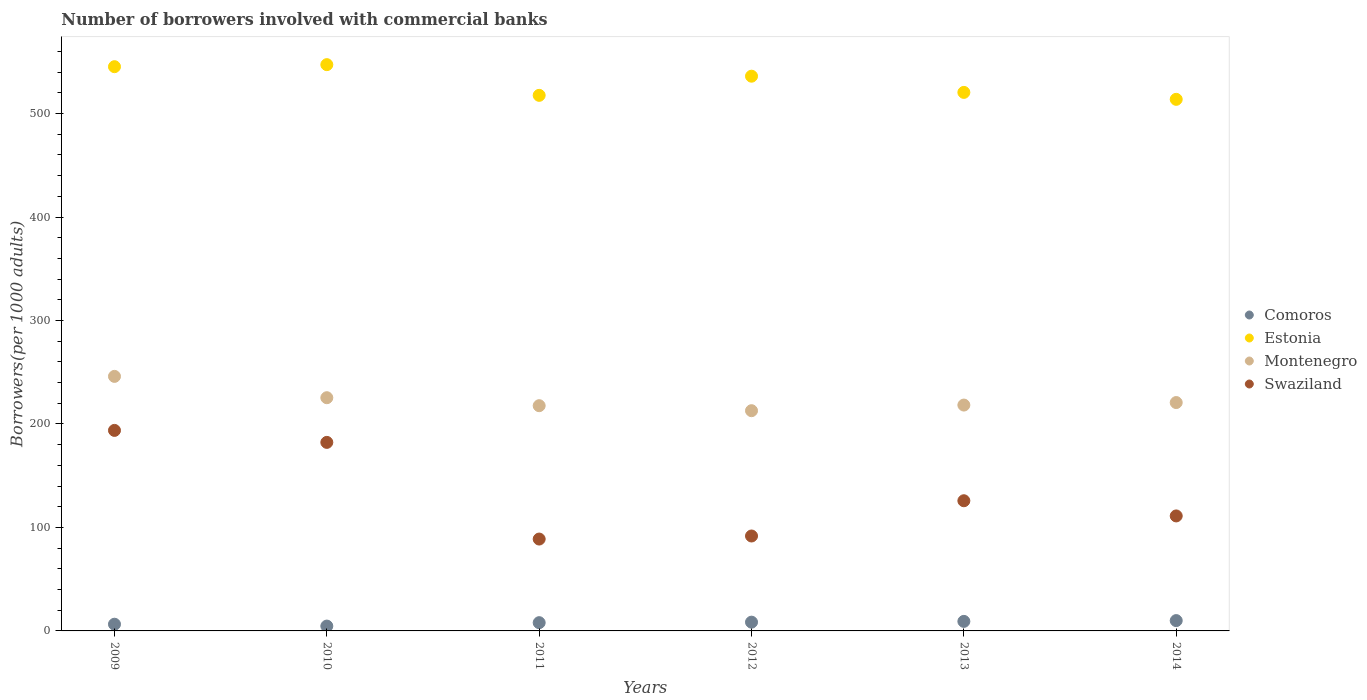How many different coloured dotlines are there?
Make the answer very short. 4. Is the number of dotlines equal to the number of legend labels?
Provide a short and direct response. Yes. What is the number of borrowers involved with commercial banks in Montenegro in 2012?
Ensure brevity in your answer.  212.85. Across all years, what is the maximum number of borrowers involved with commercial banks in Comoros?
Give a very brief answer. 9.98. Across all years, what is the minimum number of borrowers involved with commercial banks in Swaziland?
Your response must be concise. 88.79. In which year was the number of borrowers involved with commercial banks in Comoros maximum?
Your answer should be very brief. 2014. What is the total number of borrowers involved with commercial banks in Swaziland in the graph?
Offer a very short reply. 793.53. What is the difference between the number of borrowers involved with commercial banks in Swaziland in 2009 and that in 2014?
Your answer should be very brief. 82.67. What is the difference between the number of borrowers involved with commercial banks in Montenegro in 2009 and the number of borrowers involved with commercial banks in Comoros in 2010?
Ensure brevity in your answer.  241.33. What is the average number of borrowers involved with commercial banks in Estonia per year?
Provide a succinct answer. 530.13. In the year 2011, what is the difference between the number of borrowers involved with commercial banks in Comoros and number of borrowers involved with commercial banks in Swaziland?
Offer a very short reply. -80.82. What is the ratio of the number of borrowers involved with commercial banks in Montenegro in 2009 to that in 2014?
Ensure brevity in your answer.  1.11. Is the number of borrowers involved with commercial banks in Montenegro in 2009 less than that in 2014?
Your response must be concise. No. What is the difference between the highest and the second highest number of borrowers involved with commercial banks in Swaziland?
Offer a very short reply. 11.59. What is the difference between the highest and the lowest number of borrowers involved with commercial banks in Montenegro?
Your answer should be very brief. 33.16. In how many years, is the number of borrowers involved with commercial banks in Estonia greater than the average number of borrowers involved with commercial banks in Estonia taken over all years?
Your answer should be compact. 3. Is the sum of the number of borrowers involved with commercial banks in Swaziland in 2010 and 2014 greater than the maximum number of borrowers involved with commercial banks in Estonia across all years?
Your response must be concise. No. Is it the case that in every year, the sum of the number of borrowers involved with commercial banks in Estonia and number of borrowers involved with commercial banks in Comoros  is greater than the sum of number of borrowers involved with commercial banks in Swaziland and number of borrowers involved with commercial banks in Montenegro?
Your answer should be very brief. Yes. Does the number of borrowers involved with commercial banks in Estonia monotonically increase over the years?
Your answer should be very brief. No. How many years are there in the graph?
Give a very brief answer. 6. What is the difference between two consecutive major ticks on the Y-axis?
Ensure brevity in your answer.  100. How many legend labels are there?
Offer a terse response. 4. How are the legend labels stacked?
Make the answer very short. Vertical. What is the title of the graph?
Ensure brevity in your answer.  Number of borrowers involved with commercial banks. What is the label or title of the X-axis?
Give a very brief answer. Years. What is the label or title of the Y-axis?
Your answer should be very brief. Borrowers(per 1000 adults). What is the Borrowers(per 1000 adults) in Comoros in 2009?
Provide a short and direct response. 6.48. What is the Borrowers(per 1000 adults) in Estonia in 2009?
Give a very brief answer. 545.35. What is the Borrowers(per 1000 adults) of Montenegro in 2009?
Ensure brevity in your answer.  246.02. What is the Borrowers(per 1000 adults) of Swaziland in 2009?
Offer a very short reply. 193.81. What is the Borrowers(per 1000 adults) of Comoros in 2010?
Ensure brevity in your answer.  4.68. What is the Borrowers(per 1000 adults) in Estonia in 2010?
Provide a succinct answer. 547.32. What is the Borrowers(per 1000 adults) in Montenegro in 2010?
Provide a succinct answer. 225.41. What is the Borrowers(per 1000 adults) in Swaziland in 2010?
Your response must be concise. 182.22. What is the Borrowers(per 1000 adults) of Comoros in 2011?
Make the answer very short. 7.98. What is the Borrowers(per 1000 adults) of Estonia in 2011?
Offer a very short reply. 517.65. What is the Borrowers(per 1000 adults) in Montenegro in 2011?
Ensure brevity in your answer.  217.69. What is the Borrowers(per 1000 adults) in Swaziland in 2011?
Make the answer very short. 88.79. What is the Borrowers(per 1000 adults) in Comoros in 2012?
Provide a short and direct response. 8.47. What is the Borrowers(per 1000 adults) of Estonia in 2012?
Provide a succinct answer. 536.16. What is the Borrowers(per 1000 adults) of Montenegro in 2012?
Make the answer very short. 212.85. What is the Borrowers(per 1000 adults) in Swaziland in 2012?
Your answer should be compact. 91.75. What is the Borrowers(per 1000 adults) of Comoros in 2013?
Ensure brevity in your answer.  9.21. What is the Borrowers(per 1000 adults) in Estonia in 2013?
Your response must be concise. 520.5. What is the Borrowers(per 1000 adults) of Montenegro in 2013?
Make the answer very short. 218.3. What is the Borrowers(per 1000 adults) in Swaziland in 2013?
Provide a succinct answer. 125.82. What is the Borrowers(per 1000 adults) in Comoros in 2014?
Offer a terse response. 9.98. What is the Borrowers(per 1000 adults) of Estonia in 2014?
Offer a very short reply. 513.79. What is the Borrowers(per 1000 adults) in Montenegro in 2014?
Your answer should be very brief. 220.72. What is the Borrowers(per 1000 adults) of Swaziland in 2014?
Ensure brevity in your answer.  111.14. Across all years, what is the maximum Borrowers(per 1000 adults) of Comoros?
Make the answer very short. 9.98. Across all years, what is the maximum Borrowers(per 1000 adults) of Estonia?
Offer a very short reply. 547.32. Across all years, what is the maximum Borrowers(per 1000 adults) of Montenegro?
Make the answer very short. 246.02. Across all years, what is the maximum Borrowers(per 1000 adults) in Swaziland?
Make the answer very short. 193.81. Across all years, what is the minimum Borrowers(per 1000 adults) of Comoros?
Your answer should be compact. 4.68. Across all years, what is the minimum Borrowers(per 1000 adults) in Estonia?
Offer a terse response. 513.79. Across all years, what is the minimum Borrowers(per 1000 adults) in Montenegro?
Offer a terse response. 212.85. Across all years, what is the minimum Borrowers(per 1000 adults) in Swaziland?
Provide a short and direct response. 88.79. What is the total Borrowers(per 1000 adults) of Comoros in the graph?
Offer a terse response. 46.79. What is the total Borrowers(per 1000 adults) of Estonia in the graph?
Offer a terse response. 3180.77. What is the total Borrowers(per 1000 adults) of Montenegro in the graph?
Provide a succinct answer. 1340.98. What is the total Borrowers(per 1000 adults) in Swaziland in the graph?
Ensure brevity in your answer.  793.53. What is the difference between the Borrowers(per 1000 adults) of Comoros in 2009 and that in 2010?
Offer a very short reply. 1.79. What is the difference between the Borrowers(per 1000 adults) in Estonia in 2009 and that in 2010?
Make the answer very short. -1.97. What is the difference between the Borrowers(per 1000 adults) of Montenegro in 2009 and that in 2010?
Keep it short and to the point. 20.61. What is the difference between the Borrowers(per 1000 adults) of Swaziland in 2009 and that in 2010?
Keep it short and to the point. 11.59. What is the difference between the Borrowers(per 1000 adults) of Comoros in 2009 and that in 2011?
Offer a very short reply. -1.5. What is the difference between the Borrowers(per 1000 adults) in Estonia in 2009 and that in 2011?
Make the answer very short. 27.7. What is the difference between the Borrowers(per 1000 adults) of Montenegro in 2009 and that in 2011?
Offer a terse response. 28.33. What is the difference between the Borrowers(per 1000 adults) in Swaziland in 2009 and that in 2011?
Your response must be concise. 105.02. What is the difference between the Borrowers(per 1000 adults) in Comoros in 2009 and that in 2012?
Your response must be concise. -1.99. What is the difference between the Borrowers(per 1000 adults) in Estonia in 2009 and that in 2012?
Your response must be concise. 9.19. What is the difference between the Borrowers(per 1000 adults) in Montenegro in 2009 and that in 2012?
Provide a short and direct response. 33.16. What is the difference between the Borrowers(per 1000 adults) in Swaziland in 2009 and that in 2012?
Provide a short and direct response. 102.06. What is the difference between the Borrowers(per 1000 adults) in Comoros in 2009 and that in 2013?
Offer a terse response. -2.74. What is the difference between the Borrowers(per 1000 adults) in Estonia in 2009 and that in 2013?
Your answer should be compact. 24.85. What is the difference between the Borrowers(per 1000 adults) of Montenegro in 2009 and that in 2013?
Offer a terse response. 27.72. What is the difference between the Borrowers(per 1000 adults) of Swaziland in 2009 and that in 2013?
Give a very brief answer. 67.99. What is the difference between the Borrowers(per 1000 adults) of Comoros in 2009 and that in 2014?
Your answer should be compact. -3.5. What is the difference between the Borrowers(per 1000 adults) in Estonia in 2009 and that in 2014?
Offer a very short reply. 31.56. What is the difference between the Borrowers(per 1000 adults) in Montenegro in 2009 and that in 2014?
Offer a terse response. 25.29. What is the difference between the Borrowers(per 1000 adults) in Swaziland in 2009 and that in 2014?
Keep it short and to the point. 82.67. What is the difference between the Borrowers(per 1000 adults) in Comoros in 2010 and that in 2011?
Provide a short and direct response. -3.3. What is the difference between the Borrowers(per 1000 adults) in Estonia in 2010 and that in 2011?
Make the answer very short. 29.67. What is the difference between the Borrowers(per 1000 adults) of Montenegro in 2010 and that in 2011?
Your answer should be compact. 7.72. What is the difference between the Borrowers(per 1000 adults) of Swaziland in 2010 and that in 2011?
Your answer should be compact. 93.43. What is the difference between the Borrowers(per 1000 adults) in Comoros in 2010 and that in 2012?
Your answer should be very brief. -3.78. What is the difference between the Borrowers(per 1000 adults) of Estonia in 2010 and that in 2012?
Make the answer very short. 11.16. What is the difference between the Borrowers(per 1000 adults) of Montenegro in 2010 and that in 2012?
Make the answer very short. 12.55. What is the difference between the Borrowers(per 1000 adults) of Swaziland in 2010 and that in 2012?
Offer a very short reply. 90.48. What is the difference between the Borrowers(per 1000 adults) in Comoros in 2010 and that in 2013?
Offer a very short reply. -4.53. What is the difference between the Borrowers(per 1000 adults) of Estonia in 2010 and that in 2013?
Your response must be concise. 26.82. What is the difference between the Borrowers(per 1000 adults) in Montenegro in 2010 and that in 2013?
Make the answer very short. 7.11. What is the difference between the Borrowers(per 1000 adults) in Swaziland in 2010 and that in 2013?
Provide a succinct answer. 56.4. What is the difference between the Borrowers(per 1000 adults) of Comoros in 2010 and that in 2014?
Your answer should be compact. -5.3. What is the difference between the Borrowers(per 1000 adults) in Estonia in 2010 and that in 2014?
Give a very brief answer. 33.53. What is the difference between the Borrowers(per 1000 adults) of Montenegro in 2010 and that in 2014?
Your response must be concise. 4.68. What is the difference between the Borrowers(per 1000 adults) in Swaziland in 2010 and that in 2014?
Your answer should be very brief. 71.08. What is the difference between the Borrowers(per 1000 adults) in Comoros in 2011 and that in 2012?
Your answer should be very brief. -0.49. What is the difference between the Borrowers(per 1000 adults) of Estonia in 2011 and that in 2012?
Your answer should be very brief. -18.51. What is the difference between the Borrowers(per 1000 adults) of Montenegro in 2011 and that in 2012?
Make the answer very short. 4.83. What is the difference between the Borrowers(per 1000 adults) in Swaziland in 2011 and that in 2012?
Ensure brevity in your answer.  -2.95. What is the difference between the Borrowers(per 1000 adults) in Comoros in 2011 and that in 2013?
Offer a terse response. -1.23. What is the difference between the Borrowers(per 1000 adults) of Estonia in 2011 and that in 2013?
Offer a very short reply. -2.85. What is the difference between the Borrowers(per 1000 adults) in Montenegro in 2011 and that in 2013?
Provide a short and direct response. -0.61. What is the difference between the Borrowers(per 1000 adults) of Swaziland in 2011 and that in 2013?
Keep it short and to the point. -37.03. What is the difference between the Borrowers(per 1000 adults) in Comoros in 2011 and that in 2014?
Offer a very short reply. -2. What is the difference between the Borrowers(per 1000 adults) in Estonia in 2011 and that in 2014?
Offer a terse response. 3.86. What is the difference between the Borrowers(per 1000 adults) of Montenegro in 2011 and that in 2014?
Your answer should be compact. -3.03. What is the difference between the Borrowers(per 1000 adults) in Swaziland in 2011 and that in 2014?
Offer a terse response. -22.35. What is the difference between the Borrowers(per 1000 adults) in Comoros in 2012 and that in 2013?
Your answer should be very brief. -0.75. What is the difference between the Borrowers(per 1000 adults) in Estonia in 2012 and that in 2013?
Offer a very short reply. 15.66. What is the difference between the Borrowers(per 1000 adults) of Montenegro in 2012 and that in 2013?
Offer a terse response. -5.44. What is the difference between the Borrowers(per 1000 adults) of Swaziland in 2012 and that in 2013?
Keep it short and to the point. -34.08. What is the difference between the Borrowers(per 1000 adults) of Comoros in 2012 and that in 2014?
Provide a short and direct response. -1.51. What is the difference between the Borrowers(per 1000 adults) in Estonia in 2012 and that in 2014?
Offer a very short reply. 22.37. What is the difference between the Borrowers(per 1000 adults) in Montenegro in 2012 and that in 2014?
Your answer should be compact. -7.87. What is the difference between the Borrowers(per 1000 adults) of Swaziland in 2012 and that in 2014?
Offer a terse response. -19.4. What is the difference between the Borrowers(per 1000 adults) in Comoros in 2013 and that in 2014?
Provide a short and direct response. -0.77. What is the difference between the Borrowers(per 1000 adults) of Estonia in 2013 and that in 2014?
Make the answer very short. 6.71. What is the difference between the Borrowers(per 1000 adults) in Montenegro in 2013 and that in 2014?
Your response must be concise. -2.42. What is the difference between the Borrowers(per 1000 adults) in Swaziland in 2013 and that in 2014?
Your response must be concise. 14.68. What is the difference between the Borrowers(per 1000 adults) in Comoros in 2009 and the Borrowers(per 1000 adults) in Estonia in 2010?
Provide a short and direct response. -540.84. What is the difference between the Borrowers(per 1000 adults) in Comoros in 2009 and the Borrowers(per 1000 adults) in Montenegro in 2010?
Give a very brief answer. -218.93. What is the difference between the Borrowers(per 1000 adults) in Comoros in 2009 and the Borrowers(per 1000 adults) in Swaziland in 2010?
Make the answer very short. -175.75. What is the difference between the Borrowers(per 1000 adults) in Estonia in 2009 and the Borrowers(per 1000 adults) in Montenegro in 2010?
Your answer should be compact. 319.94. What is the difference between the Borrowers(per 1000 adults) of Estonia in 2009 and the Borrowers(per 1000 adults) of Swaziland in 2010?
Offer a terse response. 363.13. What is the difference between the Borrowers(per 1000 adults) of Montenegro in 2009 and the Borrowers(per 1000 adults) of Swaziland in 2010?
Your response must be concise. 63.79. What is the difference between the Borrowers(per 1000 adults) of Comoros in 2009 and the Borrowers(per 1000 adults) of Estonia in 2011?
Your answer should be compact. -511.17. What is the difference between the Borrowers(per 1000 adults) of Comoros in 2009 and the Borrowers(per 1000 adults) of Montenegro in 2011?
Offer a terse response. -211.21. What is the difference between the Borrowers(per 1000 adults) of Comoros in 2009 and the Borrowers(per 1000 adults) of Swaziland in 2011?
Ensure brevity in your answer.  -82.32. What is the difference between the Borrowers(per 1000 adults) in Estonia in 2009 and the Borrowers(per 1000 adults) in Montenegro in 2011?
Make the answer very short. 327.66. What is the difference between the Borrowers(per 1000 adults) in Estonia in 2009 and the Borrowers(per 1000 adults) in Swaziland in 2011?
Provide a short and direct response. 456.56. What is the difference between the Borrowers(per 1000 adults) of Montenegro in 2009 and the Borrowers(per 1000 adults) of Swaziland in 2011?
Offer a very short reply. 157.22. What is the difference between the Borrowers(per 1000 adults) of Comoros in 2009 and the Borrowers(per 1000 adults) of Estonia in 2012?
Your response must be concise. -529.68. What is the difference between the Borrowers(per 1000 adults) of Comoros in 2009 and the Borrowers(per 1000 adults) of Montenegro in 2012?
Ensure brevity in your answer.  -206.38. What is the difference between the Borrowers(per 1000 adults) in Comoros in 2009 and the Borrowers(per 1000 adults) in Swaziland in 2012?
Your response must be concise. -85.27. What is the difference between the Borrowers(per 1000 adults) in Estonia in 2009 and the Borrowers(per 1000 adults) in Montenegro in 2012?
Offer a very short reply. 332.5. What is the difference between the Borrowers(per 1000 adults) of Estonia in 2009 and the Borrowers(per 1000 adults) of Swaziland in 2012?
Your response must be concise. 453.6. What is the difference between the Borrowers(per 1000 adults) of Montenegro in 2009 and the Borrowers(per 1000 adults) of Swaziland in 2012?
Offer a terse response. 154.27. What is the difference between the Borrowers(per 1000 adults) of Comoros in 2009 and the Borrowers(per 1000 adults) of Estonia in 2013?
Keep it short and to the point. -514.02. What is the difference between the Borrowers(per 1000 adults) in Comoros in 2009 and the Borrowers(per 1000 adults) in Montenegro in 2013?
Give a very brief answer. -211.82. What is the difference between the Borrowers(per 1000 adults) in Comoros in 2009 and the Borrowers(per 1000 adults) in Swaziland in 2013?
Ensure brevity in your answer.  -119.35. What is the difference between the Borrowers(per 1000 adults) in Estonia in 2009 and the Borrowers(per 1000 adults) in Montenegro in 2013?
Your answer should be very brief. 327.05. What is the difference between the Borrowers(per 1000 adults) in Estonia in 2009 and the Borrowers(per 1000 adults) in Swaziland in 2013?
Make the answer very short. 419.53. What is the difference between the Borrowers(per 1000 adults) in Montenegro in 2009 and the Borrowers(per 1000 adults) in Swaziland in 2013?
Ensure brevity in your answer.  120.19. What is the difference between the Borrowers(per 1000 adults) in Comoros in 2009 and the Borrowers(per 1000 adults) in Estonia in 2014?
Your answer should be very brief. -507.32. What is the difference between the Borrowers(per 1000 adults) in Comoros in 2009 and the Borrowers(per 1000 adults) in Montenegro in 2014?
Offer a terse response. -214.25. What is the difference between the Borrowers(per 1000 adults) of Comoros in 2009 and the Borrowers(per 1000 adults) of Swaziland in 2014?
Ensure brevity in your answer.  -104.67. What is the difference between the Borrowers(per 1000 adults) in Estonia in 2009 and the Borrowers(per 1000 adults) in Montenegro in 2014?
Your response must be concise. 324.63. What is the difference between the Borrowers(per 1000 adults) of Estonia in 2009 and the Borrowers(per 1000 adults) of Swaziland in 2014?
Provide a short and direct response. 434.21. What is the difference between the Borrowers(per 1000 adults) in Montenegro in 2009 and the Borrowers(per 1000 adults) in Swaziland in 2014?
Your response must be concise. 134.87. What is the difference between the Borrowers(per 1000 adults) of Comoros in 2010 and the Borrowers(per 1000 adults) of Estonia in 2011?
Your answer should be compact. -512.97. What is the difference between the Borrowers(per 1000 adults) of Comoros in 2010 and the Borrowers(per 1000 adults) of Montenegro in 2011?
Provide a short and direct response. -213.01. What is the difference between the Borrowers(per 1000 adults) of Comoros in 2010 and the Borrowers(per 1000 adults) of Swaziland in 2011?
Make the answer very short. -84.11. What is the difference between the Borrowers(per 1000 adults) in Estonia in 2010 and the Borrowers(per 1000 adults) in Montenegro in 2011?
Make the answer very short. 329.63. What is the difference between the Borrowers(per 1000 adults) in Estonia in 2010 and the Borrowers(per 1000 adults) in Swaziland in 2011?
Make the answer very short. 458.53. What is the difference between the Borrowers(per 1000 adults) in Montenegro in 2010 and the Borrowers(per 1000 adults) in Swaziland in 2011?
Ensure brevity in your answer.  136.61. What is the difference between the Borrowers(per 1000 adults) in Comoros in 2010 and the Borrowers(per 1000 adults) in Estonia in 2012?
Keep it short and to the point. -531.48. What is the difference between the Borrowers(per 1000 adults) in Comoros in 2010 and the Borrowers(per 1000 adults) in Montenegro in 2012?
Your answer should be very brief. -208.17. What is the difference between the Borrowers(per 1000 adults) in Comoros in 2010 and the Borrowers(per 1000 adults) in Swaziland in 2012?
Ensure brevity in your answer.  -87.06. What is the difference between the Borrowers(per 1000 adults) of Estonia in 2010 and the Borrowers(per 1000 adults) of Montenegro in 2012?
Offer a terse response. 334.47. What is the difference between the Borrowers(per 1000 adults) of Estonia in 2010 and the Borrowers(per 1000 adults) of Swaziland in 2012?
Offer a very short reply. 455.57. What is the difference between the Borrowers(per 1000 adults) of Montenegro in 2010 and the Borrowers(per 1000 adults) of Swaziland in 2012?
Offer a very short reply. 133.66. What is the difference between the Borrowers(per 1000 adults) of Comoros in 2010 and the Borrowers(per 1000 adults) of Estonia in 2013?
Give a very brief answer. -515.82. What is the difference between the Borrowers(per 1000 adults) in Comoros in 2010 and the Borrowers(per 1000 adults) in Montenegro in 2013?
Your answer should be compact. -213.62. What is the difference between the Borrowers(per 1000 adults) in Comoros in 2010 and the Borrowers(per 1000 adults) in Swaziland in 2013?
Make the answer very short. -121.14. What is the difference between the Borrowers(per 1000 adults) of Estonia in 2010 and the Borrowers(per 1000 adults) of Montenegro in 2013?
Your answer should be very brief. 329.02. What is the difference between the Borrowers(per 1000 adults) in Estonia in 2010 and the Borrowers(per 1000 adults) in Swaziland in 2013?
Make the answer very short. 421.5. What is the difference between the Borrowers(per 1000 adults) of Montenegro in 2010 and the Borrowers(per 1000 adults) of Swaziland in 2013?
Provide a succinct answer. 99.59. What is the difference between the Borrowers(per 1000 adults) of Comoros in 2010 and the Borrowers(per 1000 adults) of Estonia in 2014?
Keep it short and to the point. -509.11. What is the difference between the Borrowers(per 1000 adults) of Comoros in 2010 and the Borrowers(per 1000 adults) of Montenegro in 2014?
Offer a terse response. -216.04. What is the difference between the Borrowers(per 1000 adults) of Comoros in 2010 and the Borrowers(per 1000 adults) of Swaziland in 2014?
Your response must be concise. -106.46. What is the difference between the Borrowers(per 1000 adults) in Estonia in 2010 and the Borrowers(per 1000 adults) in Montenegro in 2014?
Offer a terse response. 326.6. What is the difference between the Borrowers(per 1000 adults) in Estonia in 2010 and the Borrowers(per 1000 adults) in Swaziland in 2014?
Your answer should be compact. 436.18. What is the difference between the Borrowers(per 1000 adults) of Montenegro in 2010 and the Borrowers(per 1000 adults) of Swaziland in 2014?
Provide a short and direct response. 114.27. What is the difference between the Borrowers(per 1000 adults) in Comoros in 2011 and the Borrowers(per 1000 adults) in Estonia in 2012?
Your answer should be compact. -528.18. What is the difference between the Borrowers(per 1000 adults) of Comoros in 2011 and the Borrowers(per 1000 adults) of Montenegro in 2012?
Your answer should be compact. -204.88. What is the difference between the Borrowers(per 1000 adults) in Comoros in 2011 and the Borrowers(per 1000 adults) in Swaziland in 2012?
Give a very brief answer. -83.77. What is the difference between the Borrowers(per 1000 adults) of Estonia in 2011 and the Borrowers(per 1000 adults) of Montenegro in 2012?
Your answer should be compact. 304.79. What is the difference between the Borrowers(per 1000 adults) in Estonia in 2011 and the Borrowers(per 1000 adults) in Swaziland in 2012?
Offer a very short reply. 425.9. What is the difference between the Borrowers(per 1000 adults) in Montenegro in 2011 and the Borrowers(per 1000 adults) in Swaziland in 2012?
Give a very brief answer. 125.94. What is the difference between the Borrowers(per 1000 adults) of Comoros in 2011 and the Borrowers(per 1000 adults) of Estonia in 2013?
Ensure brevity in your answer.  -512.52. What is the difference between the Borrowers(per 1000 adults) in Comoros in 2011 and the Borrowers(per 1000 adults) in Montenegro in 2013?
Your response must be concise. -210.32. What is the difference between the Borrowers(per 1000 adults) in Comoros in 2011 and the Borrowers(per 1000 adults) in Swaziland in 2013?
Give a very brief answer. -117.84. What is the difference between the Borrowers(per 1000 adults) of Estonia in 2011 and the Borrowers(per 1000 adults) of Montenegro in 2013?
Offer a terse response. 299.35. What is the difference between the Borrowers(per 1000 adults) in Estonia in 2011 and the Borrowers(per 1000 adults) in Swaziland in 2013?
Offer a terse response. 391.83. What is the difference between the Borrowers(per 1000 adults) in Montenegro in 2011 and the Borrowers(per 1000 adults) in Swaziland in 2013?
Your answer should be very brief. 91.87. What is the difference between the Borrowers(per 1000 adults) in Comoros in 2011 and the Borrowers(per 1000 adults) in Estonia in 2014?
Ensure brevity in your answer.  -505.81. What is the difference between the Borrowers(per 1000 adults) of Comoros in 2011 and the Borrowers(per 1000 adults) of Montenegro in 2014?
Your answer should be very brief. -212.74. What is the difference between the Borrowers(per 1000 adults) in Comoros in 2011 and the Borrowers(per 1000 adults) in Swaziland in 2014?
Ensure brevity in your answer.  -103.16. What is the difference between the Borrowers(per 1000 adults) in Estonia in 2011 and the Borrowers(per 1000 adults) in Montenegro in 2014?
Make the answer very short. 296.93. What is the difference between the Borrowers(per 1000 adults) of Estonia in 2011 and the Borrowers(per 1000 adults) of Swaziland in 2014?
Ensure brevity in your answer.  406.51. What is the difference between the Borrowers(per 1000 adults) in Montenegro in 2011 and the Borrowers(per 1000 adults) in Swaziland in 2014?
Your response must be concise. 106.55. What is the difference between the Borrowers(per 1000 adults) in Comoros in 2012 and the Borrowers(per 1000 adults) in Estonia in 2013?
Keep it short and to the point. -512.03. What is the difference between the Borrowers(per 1000 adults) of Comoros in 2012 and the Borrowers(per 1000 adults) of Montenegro in 2013?
Your answer should be very brief. -209.83. What is the difference between the Borrowers(per 1000 adults) in Comoros in 2012 and the Borrowers(per 1000 adults) in Swaziland in 2013?
Your response must be concise. -117.35. What is the difference between the Borrowers(per 1000 adults) of Estonia in 2012 and the Borrowers(per 1000 adults) of Montenegro in 2013?
Provide a succinct answer. 317.86. What is the difference between the Borrowers(per 1000 adults) in Estonia in 2012 and the Borrowers(per 1000 adults) in Swaziland in 2013?
Ensure brevity in your answer.  410.34. What is the difference between the Borrowers(per 1000 adults) in Montenegro in 2012 and the Borrowers(per 1000 adults) in Swaziland in 2013?
Your answer should be compact. 87.03. What is the difference between the Borrowers(per 1000 adults) of Comoros in 2012 and the Borrowers(per 1000 adults) of Estonia in 2014?
Your answer should be compact. -505.33. What is the difference between the Borrowers(per 1000 adults) of Comoros in 2012 and the Borrowers(per 1000 adults) of Montenegro in 2014?
Your answer should be very brief. -212.26. What is the difference between the Borrowers(per 1000 adults) of Comoros in 2012 and the Borrowers(per 1000 adults) of Swaziland in 2014?
Offer a very short reply. -102.68. What is the difference between the Borrowers(per 1000 adults) of Estonia in 2012 and the Borrowers(per 1000 adults) of Montenegro in 2014?
Offer a terse response. 315.44. What is the difference between the Borrowers(per 1000 adults) in Estonia in 2012 and the Borrowers(per 1000 adults) in Swaziland in 2014?
Your response must be concise. 425.02. What is the difference between the Borrowers(per 1000 adults) of Montenegro in 2012 and the Borrowers(per 1000 adults) of Swaziland in 2014?
Your response must be concise. 101.71. What is the difference between the Borrowers(per 1000 adults) in Comoros in 2013 and the Borrowers(per 1000 adults) in Estonia in 2014?
Give a very brief answer. -504.58. What is the difference between the Borrowers(per 1000 adults) of Comoros in 2013 and the Borrowers(per 1000 adults) of Montenegro in 2014?
Offer a terse response. -211.51. What is the difference between the Borrowers(per 1000 adults) in Comoros in 2013 and the Borrowers(per 1000 adults) in Swaziland in 2014?
Keep it short and to the point. -101.93. What is the difference between the Borrowers(per 1000 adults) in Estonia in 2013 and the Borrowers(per 1000 adults) in Montenegro in 2014?
Offer a very short reply. 299.78. What is the difference between the Borrowers(per 1000 adults) of Estonia in 2013 and the Borrowers(per 1000 adults) of Swaziland in 2014?
Your answer should be compact. 409.36. What is the difference between the Borrowers(per 1000 adults) in Montenegro in 2013 and the Borrowers(per 1000 adults) in Swaziland in 2014?
Give a very brief answer. 107.16. What is the average Borrowers(per 1000 adults) in Comoros per year?
Your answer should be compact. 7.8. What is the average Borrowers(per 1000 adults) of Estonia per year?
Offer a very short reply. 530.13. What is the average Borrowers(per 1000 adults) in Montenegro per year?
Offer a terse response. 223.5. What is the average Borrowers(per 1000 adults) in Swaziland per year?
Your answer should be very brief. 132.26. In the year 2009, what is the difference between the Borrowers(per 1000 adults) of Comoros and Borrowers(per 1000 adults) of Estonia?
Provide a succinct answer. -538.87. In the year 2009, what is the difference between the Borrowers(per 1000 adults) in Comoros and Borrowers(per 1000 adults) in Montenegro?
Ensure brevity in your answer.  -239.54. In the year 2009, what is the difference between the Borrowers(per 1000 adults) of Comoros and Borrowers(per 1000 adults) of Swaziland?
Your answer should be compact. -187.33. In the year 2009, what is the difference between the Borrowers(per 1000 adults) in Estonia and Borrowers(per 1000 adults) in Montenegro?
Your response must be concise. 299.33. In the year 2009, what is the difference between the Borrowers(per 1000 adults) of Estonia and Borrowers(per 1000 adults) of Swaziland?
Keep it short and to the point. 351.54. In the year 2009, what is the difference between the Borrowers(per 1000 adults) of Montenegro and Borrowers(per 1000 adults) of Swaziland?
Make the answer very short. 52.21. In the year 2010, what is the difference between the Borrowers(per 1000 adults) in Comoros and Borrowers(per 1000 adults) in Estonia?
Your answer should be very brief. -542.64. In the year 2010, what is the difference between the Borrowers(per 1000 adults) of Comoros and Borrowers(per 1000 adults) of Montenegro?
Offer a terse response. -220.72. In the year 2010, what is the difference between the Borrowers(per 1000 adults) of Comoros and Borrowers(per 1000 adults) of Swaziland?
Your answer should be very brief. -177.54. In the year 2010, what is the difference between the Borrowers(per 1000 adults) of Estonia and Borrowers(per 1000 adults) of Montenegro?
Give a very brief answer. 321.91. In the year 2010, what is the difference between the Borrowers(per 1000 adults) of Estonia and Borrowers(per 1000 adults) of Swaziland?
Offer a very short reply. 365.1. In the year 2010, what is the difference between the Borrowers(per 1000 adults) in Montenegro and Borrowers(per 1000 adults) in Swaziland?
Your answer should be very brief. 43.18. In the year 2011, what is the difference between the Borrowers(per 1000 adults) of Comoros and Borrowers(per 1000 adults) of Estonia?
Provide a short and direct response. -509.67. In the year 2011, what is the difference between the Borrowers(per 1000 adults) of Comoros and Borrowers(per 1000 adults) of Montenegro?
Your response must be concise. -209.71. In the year 2011, what is the difference between the Borrowers(per 1000 adults) in Comoros and Borrowers(per 1000 adults) in Swaziland?
Make the answer very short. -80.82. In the year 2011, what is the difference between the Borrowers(per 1000 adults) in Estonia and Borrowers(per 1000 adults) in Montenegro?
Ensure brevity in your answer.  299.96. In the year 2011, what is the difference between the Borrowers(per 1000 adults) of Estonia and Borrowers(per 1000 adults) of Swaziland?
Provide a short and direct response. 428.85. In the year 2011, what is the difference between the Borrowers(per 1000 adults) of Montenegro and Borrowers(per 1000 adults) of Swaziland?
Your answer should be compact. 128.89. In the year 2012, what is the difference between the Borrowers(per 1000 adults) in Comoros and Borrowers(per 1000 adults) in Estonia?
Provide a short and direct response. -527.69. In the year 2012, what is the difference between the Borrowers(per 1000 adults) in Comoros and Borrowers(per 1000 adults) in Montenegro?
Offer a very short reply. -204.39. In the year 2012, what is the difference between the Borrowers(per 1000 adults) in Comoros and Borrowers(per 1000 adults) in Swaziland?
Your answer should be very brief. -83.28. In the year 2012, what is the difference between the Borrowers(per 1000 adults) in Estonia and Borrowers(per 1000 adults) in Montenegro?
Give a very brief answer. 323.3. In the year 2012, what is the difference between the Borrowers(per 1000 adults) in Estonia and Borrowers(per 1000 adults) in Swaziland?
Provide a succinct answer. 444.41. In the year 2012, what is the difference between the Borrowers(per 1000 adults) of Montenegro and Borrowers(per 1000 adults) of Swaziland?
Offer a very short reply. 121.11. In the year 2013, what is the difference between the Borrowers(per 1000 adults) of Comoros and Borrowers(per 1000 adults) of Estonia?
Your response must be concise. -511.29. In the year 2013, what is the difference between the Borrowers(per 1000 adults) in Comoros and Borrowers(per 1000 adults) in Montenegro?
Make the answer very short. -209.09. In the year 2013, what is the difference between the Borrowers(per 1000 adults) of Comoros and Borrowers(per 1000 adults) of Swaziland?
Your answer should be compact. -116.61. In the year 2013, what is the difference between the Borrowers(per 1000 adults) of Estonia and Borrowers(per 1000 adults) of Montenegro?
Ensure brevity in your answer.  302.2. In the year 2013, what is the difference between the Borrowers(per 1000 adults) in Estonia and Borrowers(per 1000 adults) in Swaziland?
Ensure brevity in your answer.  394.68. In the year 2013, what is the difference between the Borrowers(per 1000 adults) of Montenegro and Borrowers(per 1000 adults) of Swaziland?
Ensure brevity in your answer.  92.48. In the year 2014, what is the difference between the Borrowers(per 1000 adults) in Comoros and Borrowers(per 1000 adults) in Estonia?
Your response must be concise. -503.81. In the year 2014, what is the difference between the Borrowers(per 1000 adults) in Comoros and Borrowers(per 1000 adults) in Montenegro?
Keep it short and to the point. -210.74. In the year 2014, what is the difference between the Borrowers(per 1000 adults) in Comoros and Borrowers(per 1000 adults) in Swaziland?
Provide a succinct answer. -101.16. In the year 2014, what is the difference between the Borrowers(per 1000 adults) of Estonia and Borrowers(per 1000 adults) of Montenegro?
Make the answer very short. 293.07. In the year 2014, what is the difference between the Borrowers(per 1000 adults) of Estonia and Borrowers(per 1000 adults) of Swaziland?
Your answer should be very brief. 402.65. In the year 2014, what is the difference between the Borrowers(per 1000 adults) in Montenegro and Borrowers(per 1000 adults) in Swaziland?
Provide a succinct answer. 109.58. What is the ratio of the Borrowers(per 1000 adults) of Comoros in 2009 to that in 2010?
Offer a very short reply. 1.38. What is the ratio of the Borrowers(per 1000 adults) of Estonia in 2009 to that in 2010?
Provide a succinct answer. 1. What is the ratio of the Borrowers(per 1000 adults) in Montenegro in 2009 to that in 2010?
Your answer should be very brief. 1.09. What is the ratio of the Borrowers(per 1000 adults) of Swaziland in 2009 to that in 2010?
Keep it short and to the point. 1.06. What is the ratio of the Borrowers(per 1000 adults) of Comoros in 2009 to that in 2011?
Give a very brief answer. 0.81. What is the ratio of the Borrowers(per 1000 adults) in Estonia in 2009 to that in 2011?
Your response must be concise. 1.05. What is the ratio of the Borrowers(per 1000 adults) of Montenegro in 2009 to that in 2011?
Your answer should be compact. 1.13. What is the ratio of the Borrowers(per 1000 adults) of Swaziland in 2009 to that in 2011?
Offer a very short reply. 2.18. What is the ratio of the Borrowers(per 1000 adults) in Comoros in 2009 to that in 2012?
Offer a terse response. 0.76. What is the ratio of the Borrowers(per 1000 adults) of Estonia in 2009 to that in 2012?
Provide a succinct answer. 1.02. What is the ratio of the Borrowers(per 1000 adults) of Montenegro in 2009 to that in 2012?
Provide a succinct answer. 1.16. What is the ratio of the Borrowers(per 1000 adults) in Swaziland in 2009 to that in 2012?
Give a very brief answer. 2.11. What is the ratio of the Borrowers(per 1000 adults) of Comoros in 2009 to that in 2013?
Ensure brevity in your answer.  0.7. What is the ratio of the Borrowers(per 1000 adults) of Estonia in 2009 to that in 2013?
Keep it short and to the point. 1.05. What is the ratio of the Borrowers(per 1000 adults) in Montenegro in 2009 to that in 2013?
Ensure brevity in your answer.  1.13. What is the ratio of the Borrowers(per 1000 adults) of Swaziland in 2009 to that in 2013?
Your answer should be very brief. 1.54. What is the ratio of the Borrowers(per 1000 adults) in Comoros in 2009 to that in 2014?
Provide a short and direct response. 0.65. What is the ratio of the Borrowers(per 1000 adults) of Estonia in 2009 to that in 2014?
Your answer should be very brief. 1.06. What is the ratio of the Borrowers(per 1000 adults) in Montenegro in 2009 to that in 2014?
Make the answer very short. 1.11. What is the ratio of the Borrowers(per 1000 adults) of Swaziland in 2009 to that in 2014?
Your answer should be very brief. 1.74. What is the ratio of the Borrowers(per 1000 adults) of Comoros in 2010 to that in 2011?
Your response must be concise. 0.59. What is the ratio of the Borrowers(per 1000 adults) of Estonia in 2010 to that in 2011?
Offer a terse response. 1.06. What is the ratio of the Borrowers(per 1000 adults) of Montenegro in 2010 to that in 2011?
Your response must be concise. 1.04. What is the ratio of the Borrowers(per 1000 adults) of Swaziland in 2010 to that in 2011?
Provide a short and direct response. 2.05. What is the ratio of the Borrowers(per 1000 adults) of Comoros in 2010 to that in 2012?
Make the answer very short. 0.55. What is the ratio of the Borrowers(per 1000 adults) of Estonia in 2010 to that in 2012?
Provide a short and direct response. 1.02. What is the ratio of the Borrowers(per 1000 adults) in Montenegro in 2010 to that in 2012?
Your answer should be compact. 1.06. What is the ratio of the Borrowers(per 1000 adults) of Swaziland in 2010 to that in 2012?
Ensure brevity in your answer.  1.99. What is the ratio of the Borrowers(per 1000 adults) of Comoros in 2010 to that in 2013?
Ensure brevity in your answer.  0.51. What is the ratio of the Borrowers(per 1000 adults) of Estonia in 2010 to that in 2013?
Offer a very short reply. 1.05. What is the ratio of the Borrowers(per 1000 adults) of Montenegro in 2010 to that in 2013?
Your response must be concise. 1.03. What is the ratio of the Borrowers(per 1000 adults) in Swaziland in 2010 to that in 2013?
Make the answer very short. 1.45. What is the ratio of the Borrowers(per 1000 adults) in Comoros in 2010 to that in 2014?
Give a very brief answer. 0.47. What is the ratio of the Borrowers(per 1000 adults) in Estonia in 2010 to that in 2014?
Give a very brief answer. 1.07. What is the ratio of the Borrowers(per 1000 adults) in Montenegro in 2010 to that in 2014?
Make the answer very short. 1.02. What is the ratio of the Borrowers(per 1000 adults) in Swaziland in 2010 to that in 2014?
Make the answer very short. 1.64. What is the ratio of the Borrowers(per 1000 adults) of Comoros in 2011 to that in 2012?
Make the answer very short. 0.94. What is the ratio of the Borrowers(per 1000 adults) of Estonia in 2011 to that in 2012?
Your answer should be compact. 0.97. What is the ratio of the Borrowers(per 1000 adults) in Montenegro in 2011 to that in 2012?
Your answer should be compact. 1.02. What is the ratio of the Borrowers(per 1000 adults) in Swaziland in 2011 to that in 2012?
Offer a very short reply. 0.97. What is the ratio of the Borrowers(per 1000 adults) in Comoros in 2011 to that in 2013?
Your response must be concise. 0.87. What is the ratio of the Borrowers(per 1000 adults) of Swaziland in 2011 to that in 2013?
Give a very brief answer. 0.71. What is the ratio of the Borrowers(per 1000 adults) in Comoros in 2011 to that in 2014?
Make the answer very short. 0.8. What is the ratio of the Borrowers(per 1000 adults) of Estonia in 2011 to that in 2014?
Provide a succinct answer. 1.01. What is the ratio of the Borrowers(per 1000 adults) of Montenegro in 2011 to that in 2014?
Provide a short and direct response. 0.99. What is the ratio of the Borrowers(per 1000 adults) of Swaziland in 2011 to that in 2014?
Provide a short and direct response. 0.8. What is the ratio of the Borrowers(per 1000 adults) of Comoros in 2012 to that in 2013?
Keep it short and to the point. 0.92. What is the ratio of the Borrowers(per 1000 adults) in Estonia in 2012 to that in 2013?
Offer a very short reply. 1.03. What is the ratio of the Borrowers(per 1000 adults) of Montenegro in 2012 to that in 2013?
Make the answer very short. 0.98. What is the ratio of the Borrowers(per 1000 adults) in Swaziland in 2012 to that in 2013?
Your answer should be compact. 0.73. What is the ratio of the Borrowers(per 1000 adults) in Comoros in 2012 to that in 2014?
Offer a terse response. 0.85. What is the ratio of the Borrowers(per 1000 adults) of Estonia in 2012 to that in 2014?
Give a very brief answer. 1.04. What is the ratio of the Borrowers(per 1000 adults) in Montenegro in 2012 to that in 2014?
Provide a short and direct response. 0.96. What is the ratio of the Borrowers(per 1000 adults) of Swaziland in 2012 to that in 2014?
Ensure brevity in your answer.  0.83. What is the ratio of the Borrowers(per 1000 adults) in Comoros in 2013 to that in 2014?
Offer a terse response. 0.92. What is the ratio of the Borrowers(per 1000 adults) in Estonia in 2013 to that in 2014?
Ensure brevity in your answer.  1.01. What is the ratio of the Borrowers(per 1000 adults) in Montenegro in 2013 to that in 2014?
Your answer should be very brief. 0.99. What is the ratio of the Borrowers(per 1000 adults) in Swaziland in 2013 to that in 2014?
Make the answer very short. 1.13. What is the difference between the highest and the second highest Borrowers(per 1000 adults) in Comoros?
Make the answer very short. 0.77. What is the difference between the highest and the second highest Borrowers(per 1000 adults) of Estonia?
Your answer should be compact. 1.97. What is the difference between the highest and the second highest Borrowers(per 1000 adults) of Montenegro?
Your answer should be compact. 20.61. What is the difference between the highest and the second highest Borrowers(per 1000 adults) of Swaziland?
Offer a very short reply. 11.59. What is the difference between the highest and the lowest Borrowers(per 1000 adults) of Comoros?
Your answer should be compact. 5.3. What is the difference between the highest and the lowest Borrowers(per 1000 adults) in Estonia?
Offer a very short reply. 33.53. What is the difference between the highest and the lowest Borrowers(per 1000 adults) in Montenegro?
Your answer should be compact. 33.16. What is the difference between the highest and the lowest Borrowers(per 1000 adults) of Swaziland?
Keep it short and to the point. 105.02. 